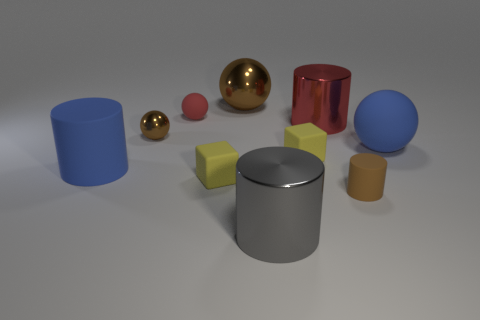How many cyan cylinders have the same size as the gray thing?
Make the answer very short. 0. How many large red cubes are there?
Provide a short and direct response. 0. Does the blue cylinder have the same material as the large blue thing behind the large blue matte cylinder?
Your answer should be compact. Yes. What number of red things are either balls or rubber cylinders?
Your response must be concise. 1. What is the size of the red thing that is the same material as the tiny brown sphere?
Your answer should be compact. Large. How many brown objects have the same shape as the gray shiny thing?
Your answer should be very brief. 1. Are there more tiny matte cubes that are left of the small matte cylinder than gray cylinders on the left side of the tiny matte sphere?
Keep it short and to the point. Yes. There is a small metallic thing; is its color the same as the small cylinder in front of the big shiny ball?
Offer a very short reply. Yes. There is a gray object that is the same size as the blue matte cylinder; what material is it?
Your answer should be compact. Metal. How many things are large yellow metallic balls or matte cylinders behind the small brown rubber cylinder?
Offer a very short reply. 1. 